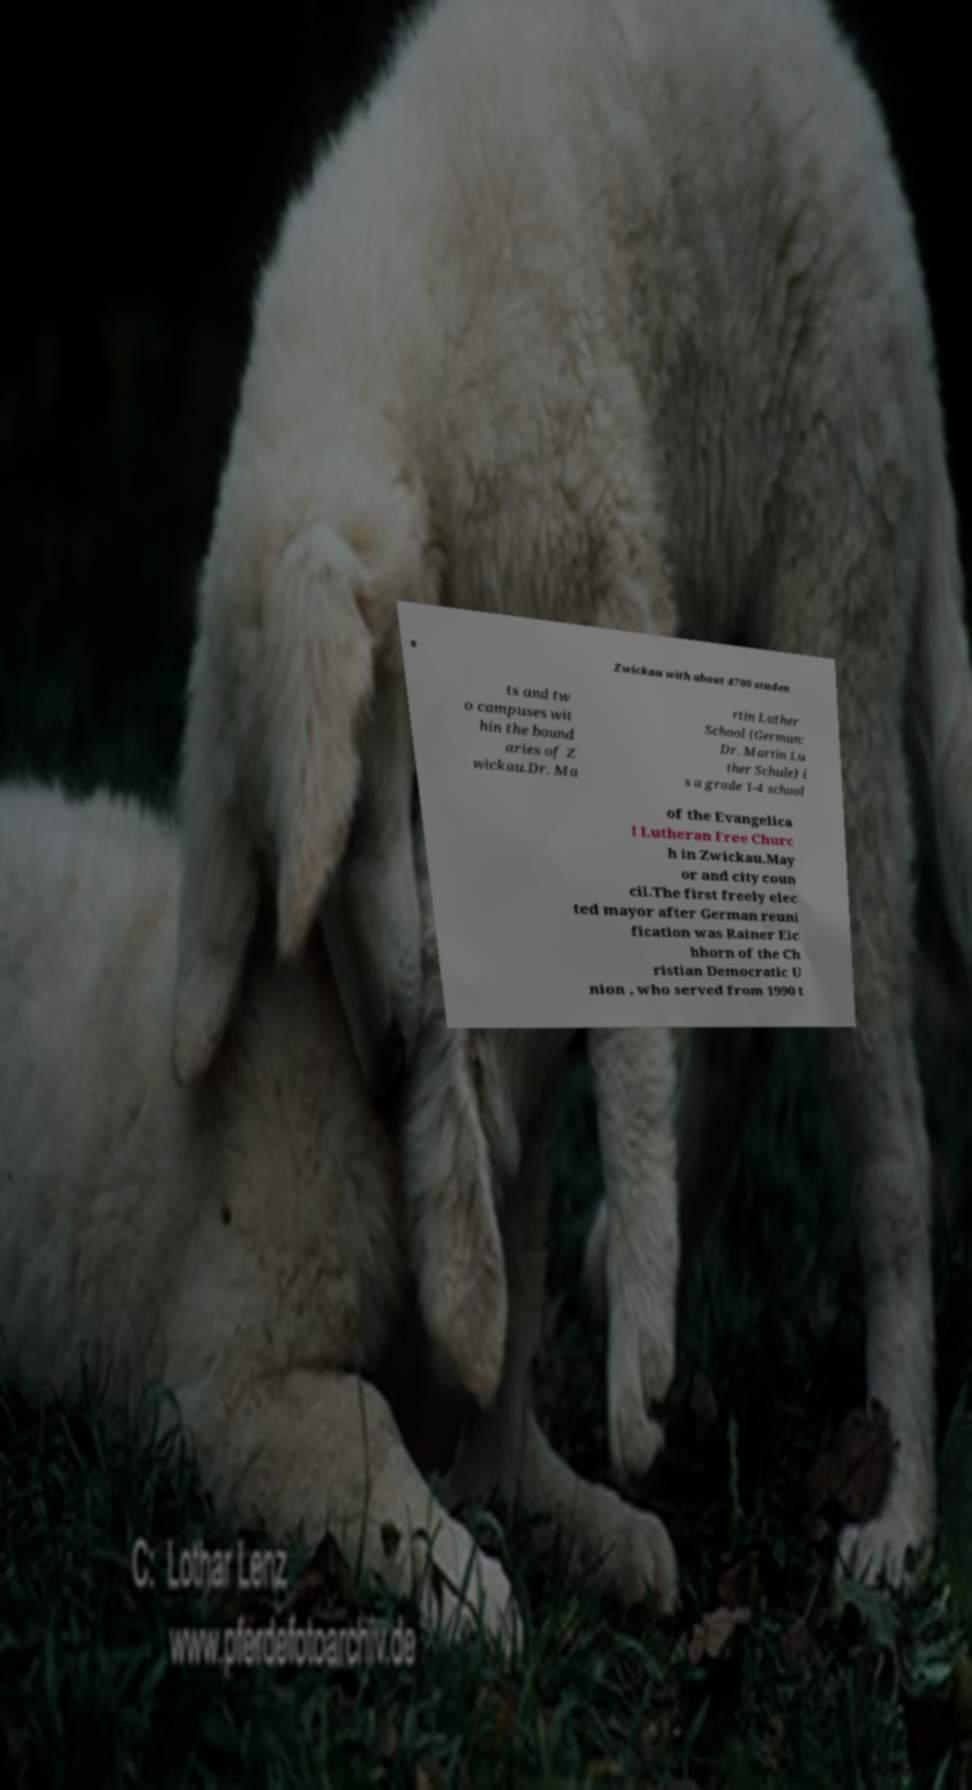Could you extract and type out the text from this image? s Zwickau with about 4700 studen ts and tw o campuses wit hin the bound aries of Z wickau.Dr. Ma rtin Luther School (German: Dr. Martin Lu ther Schule) i s a grade 1-4 school of the Evangelica l Lutheran Free Churc h in Zwickau.May or and city coun cil.The first freely elec ted mayor after German reuni fication was Rainer Eic hhorn of the Ch ristian Democratic U nion , who served from 1990 t 